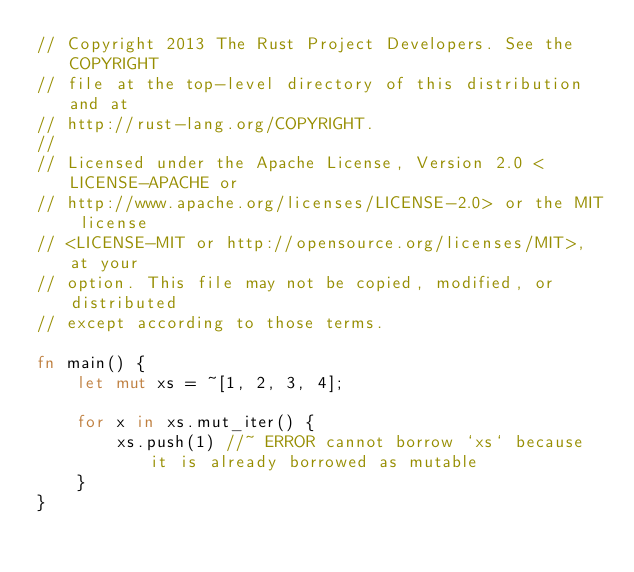Convert code to text. <code><loc_0><loc_0><loc_500><loc_500><_Rust_>// Copyright 2013 The Rust Project Developers. See the COPYRIGHT
// file at the top-level directory of this distribution and at
// http://rust-lang.org/COPYRIGHT.
//
// Licensed under the Apache License, Version 2.0 <LICENSE-APACHE or
// http://www.apache.org/licenses/LICENSE-2.0> or the MIT license
// <LICENSE-MIT or http://opensource.org/licenses/MIT>, at your
// option. This file may not be copied, modified, or distributed
// except according to those terms.

fn main() {
    let mut xs = ~[1, 2, 3, 4];

    for x in xs.mut_iter() {
        xs.push(1) //~ ERROR cannot borrow `xs` because it is already borrowed as mutable
    }
}
</code> 